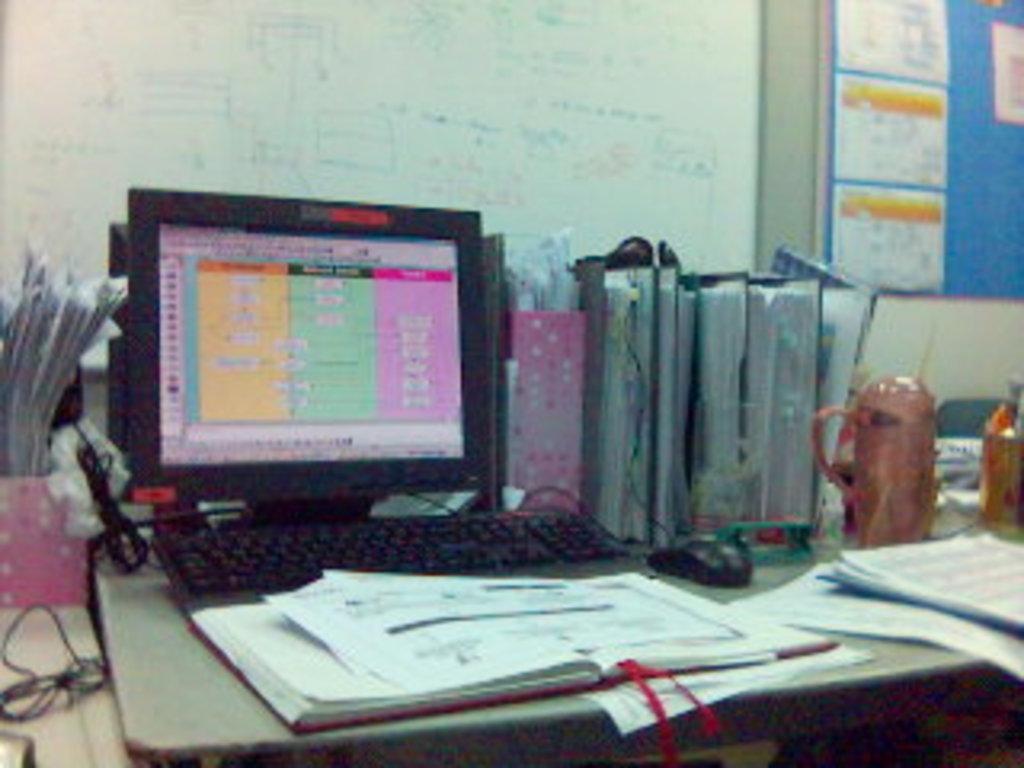Describe this image in one or two sentences. In this image there is a table. On the table there are papers, books, files, a computer, cable wires, a jar and pen holders. Behind the table there is a wall. There are boards on the wall. There is text on a whiteboard. To the right there are papers sticked on the board. 